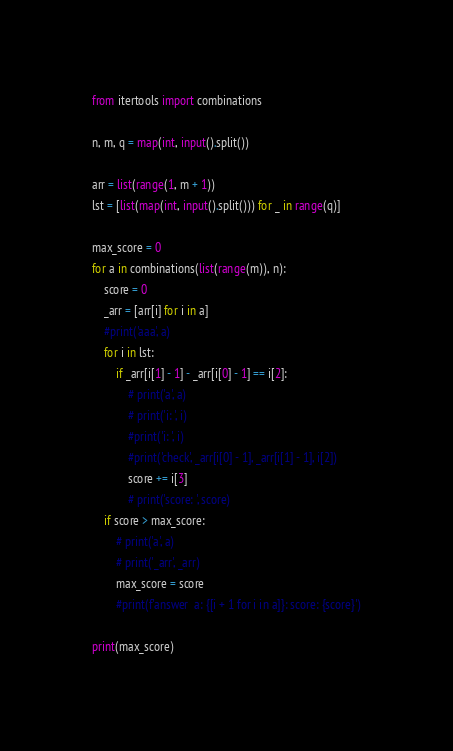Convert code to text. <code><loc_0><loc_0><loc_500><loc_500><_Python_>from itertools import combinations

n, m, q = map(int, input().split())

arr = list(range(1, m + 1))
lst = [list(map(int, input().split())) for _ in range(q)]

max_score = 0
for a in combinations(list(range(m)), n):
    score = 0
    _arr = [arr[i] for i in a]
    #print('aaa', a)
    for i in lst:
        if _arr[i[1] - 1] - _arr[i[0] - 1] == i[2]:
            # print('a', a)
            # print('i: ', i)
            #print('i: ', i)
            #print('check', _arr[i[0] - 1], _arr[i[1] - 1], i[2])
            score += i[3]
            # print('score: ', score)
    if score > max_score:
        # print('a', a)
        # print('_arr', _arr)
        max_score = score
        #print(f'answer  a: {[i + 1 for i in a]}: score: {score}')

print(max_score)</code> 